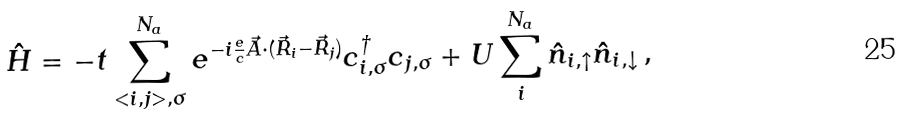Convert formula to latex. <formula><loc_0><loc_0><loc_500><loc_500>\hat { H } = - t \sum _ { < i , j > , \sigma } ^ { N _ { a } } e ^ { - i \frac { e } { c } \vec { A } \cdot ( \vec { R } _ { i } - \vec { R } _ { j } ) } c _ { i , \sigma } ^ { \dag } c _ { j , \sigma } + U \sum _ { i } ^ { N _ { a } } \hat { n } _ { i , \uparrow } \hat { n } _ { i , \downarrow } \, ,</formula> 